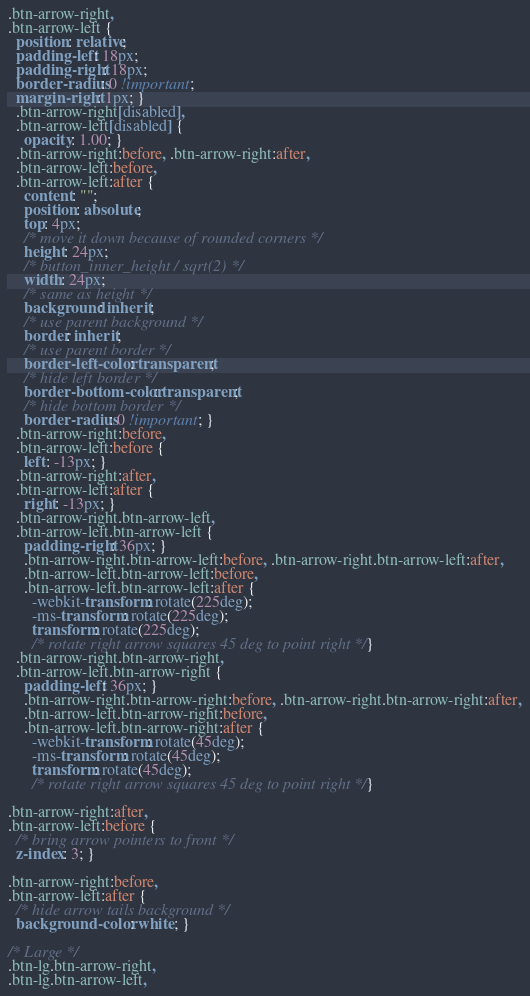Convert code to text. <code><loc_0><loc_0><loc_500><loc_500><_CSS_>.btn-arrow-right,
.btn-arrow-left {
  position: relative;
  padding-left: 18px;
  padding-right: 18px;
  border-radius: 0 !important;
  margin-right: 1px; }
  .btn-arrow-right[disabled],
  .btn-arrow-left[disabled] {
    opacity: 1.00; }
  .btn-arrow-right:before, .btn-arrow-right:after,
  .btn-arrow-left:before,
  .btn-arrow-left:after {
    content: "";
    position: absolute;
    top: 4px;
    /* move it down because of rounded corners */
    height: 24px;
    /* button_inner_height / sqrt(2) */
    width: 24px;
    /* same as height */
    background: inherit;
    /* use parent background */
    border: inherit;
    /* use parent border */
    border-left-color: transparent;
    /* hide left border */
    border-bottom-color: transparent;
    /* hide bottom border */
    border-radius: 0 !important; }
  .btn-arrow-right:before,
  .btn-arrow-left:before {
    left: -13px; }
  .btn-arrow-right:after,
  .btn-arrow-left:after {
    right: -13px; }
  .btn-arrow-right.btn-arrow-left,
  .btn-arrow-left.btn-arrow-left {
    padding-right: 36px; }
    .btn-arrow-right.btn-arrow-left:before, .btn-arrow-right.btn-arrow-left:after,
    .btn-arrow-left.btn-arrow-left:before,
    .btn-arrow-left.btn-arrow-left:after {
      -webkit-transform: rotate(225deg);
      -ms-transform: rotate(225deg);
      transform: rotate(225deg);
      /* rotate right arrow squares 45 deg to point right */ }
  .btn-arrow-right.btn-arrow-right,
  .btn-arrow-left.btn-arrow-right {
    padding-left: 36px; }
    .btn-arrow-right.btn-arrow-right:before, .btn-arrow-right.btn-arrow-right:after,
    .btn-arrow-left.btn-arrow-right:before,
    .btn-arrow-left.btn-arrow-right:after {
      -webkit-transform: rotate(45deg);
      -ms-transform: rotate(45deg);
      transform: rotate(45deg);
      /* rotate right arrow squares 45 deg to point right */ }

.btn-arrow-right:after,
.btn-arrow-left:before {
  /* bring arrow pointers to front */
  z-index: 3; }

.btn-arrow-right:before,
.btn-arrow-left:after {
  /* hide arrow tails background */
  background-color: white; }

/* Large */
.btn-lg.btn-arrow-right,
.btn-lg.btn-arrow-left,</code> 